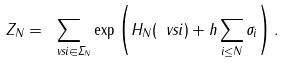Convert formula to latex. <formula><loc_0><loc_0><loc_500><loc_500>Z _ { N } = \sum _ { \ v s i \in \Sigma _ { N } } \exp \left ( H _ { N } ( \ v s i ) + h \sum _ { i \leq N } \sigma _ { i } \right ) .</formula> 